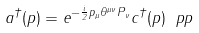<formula> <loc_0><loc_0><loc_500><loc_500>a ^ { \dagger } ( p ) = e ^ { - \frac { i } { 2 } p _ { \mu } \theta ^ { \mu \nu } P _ { \nu } } c ^ { \dagger } ( p ) \ p p</formula> 